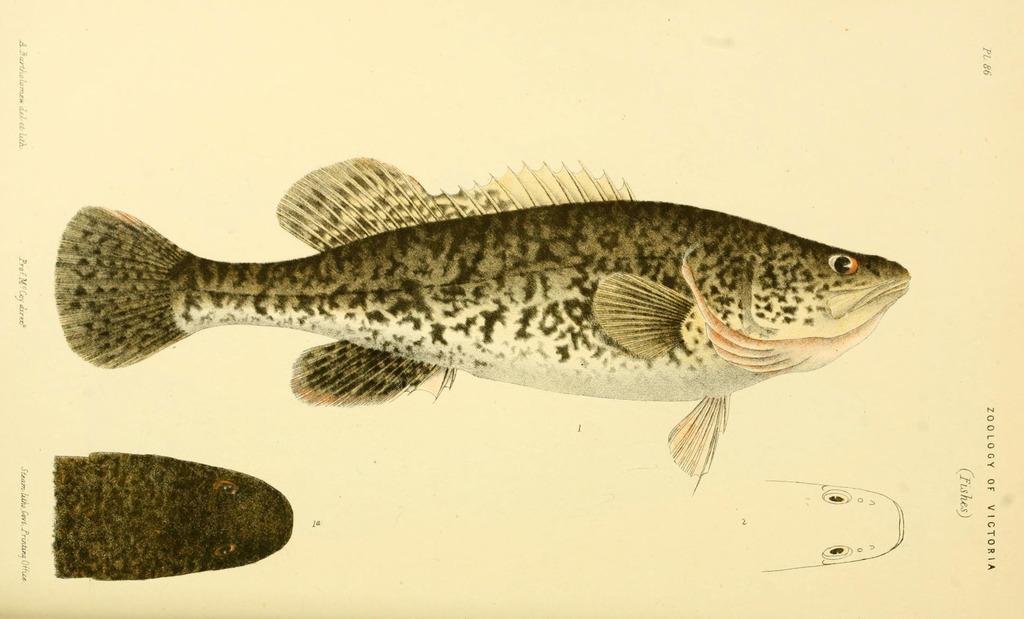Please provide a concise description of this image. In the center of the image there is a depiction of fish. 